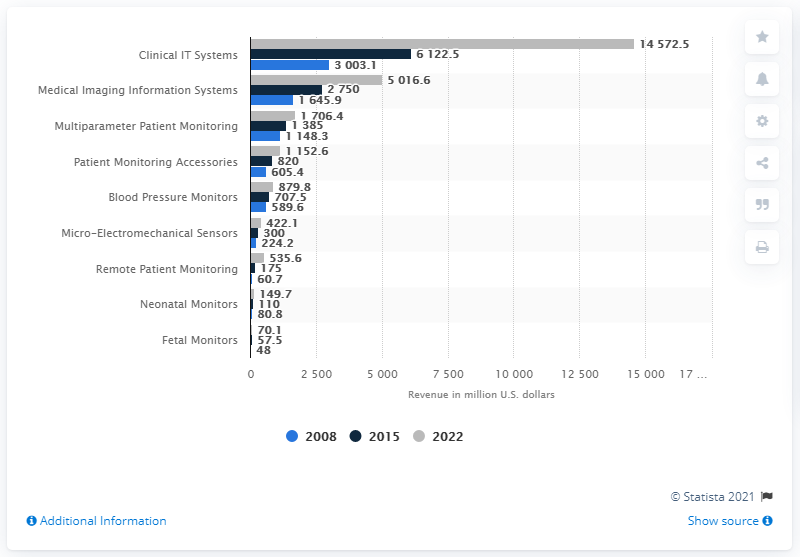Highlight a few significant elements in this photo. The expected revenue from clinical IT systems by 2022 is 14,572.5. The healthcare IT market was valued at approximately 6122.5 in 2015. 